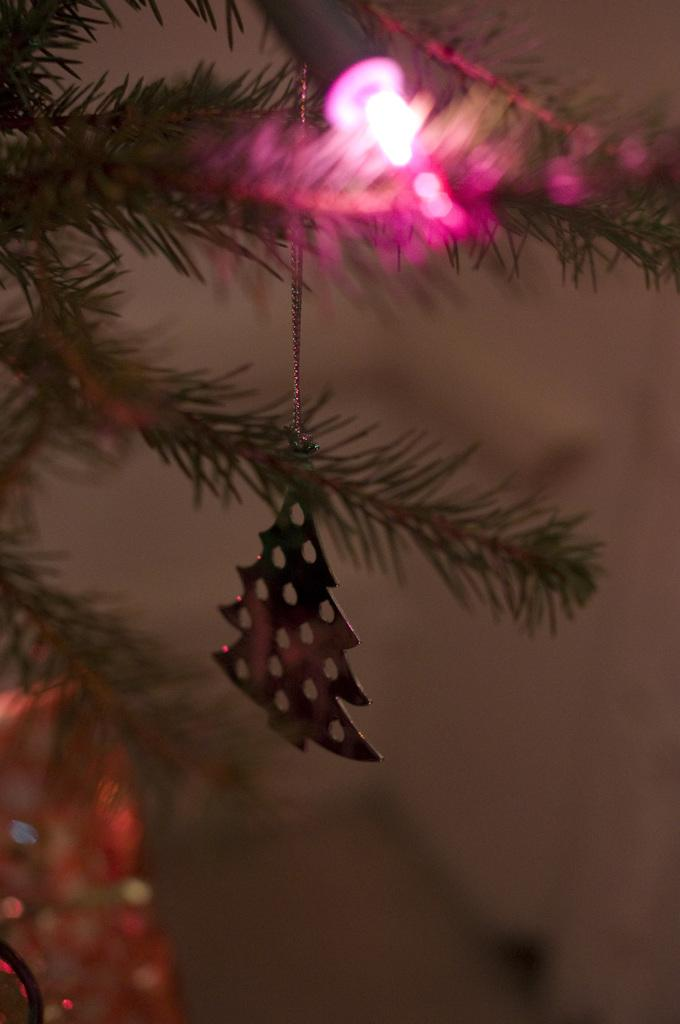What is the main subject of the image? There is a Christmas tree in the image. What color is the light on the Christmas tree? The Christmas tree has a pink colored light. What can be seen on the Christmas tree besides the light? There are decorative items on the Christmas tree. Can you describe the background of the image? The background of the image is blurry. What type of furniture is present in the image? There is no furniture visible in the image; it primarily features a Christmas tree. Can you tell me how many queens are depicted in the image? There are no queens present in the image; it features a Christmas tree with decorative items. 